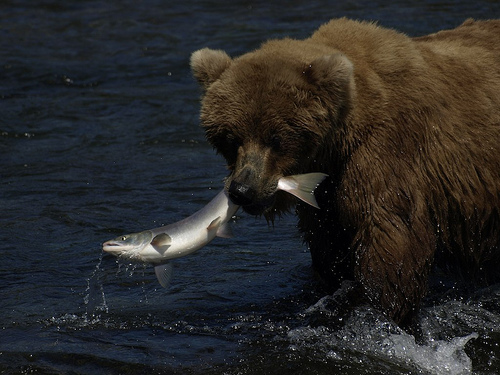How many bears are shown? 1 